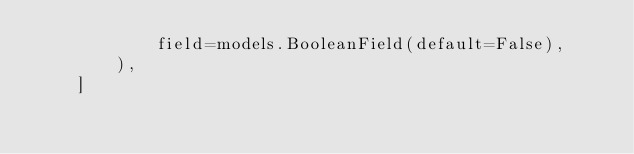<code> <loc_0><loc_0><loc_500><loc_500><_Python_>            field=models.BooleanField(default=False),
        ),
    ]
</code> 